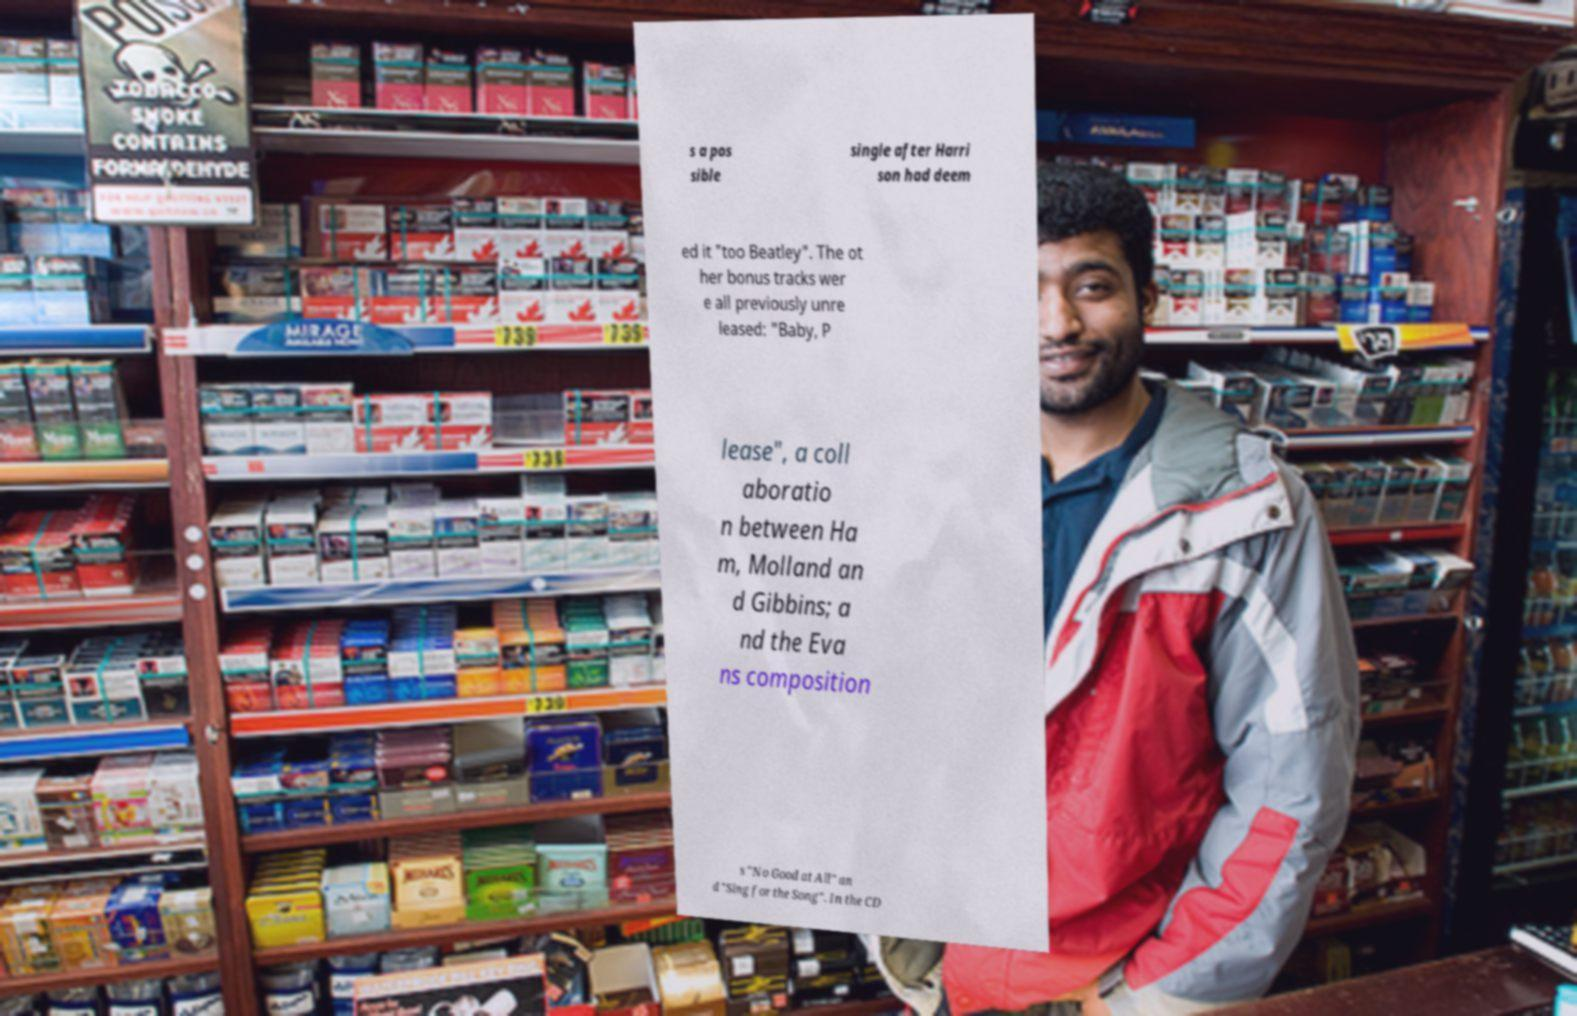Please read and relay the text visible in this image. What does it say? s a pos sible single after Harri son had deem ed it "too Beatley". The ot her bonus tracks wer e all previously unre leased: "Baby, P lease", a coll aboratio n between Ha m, Molland an d Gibbins; a nd the Eva ns composition s "No Good at All" an d "Sing for the Song". In the CD 